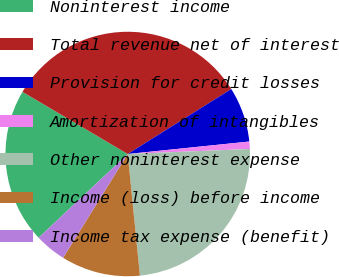<chart> <loc_0><loc_0><loc_500><loc_500><pie_chart><fcel>Noninterest income<fcel>Total revenue net of interest<fcel>Provision for credit losses<fcel>Amortization of intangibles<fcel>Other noninterest expense<fcel>Income (loss) before income<fcel>Income tax expense (benefit)<nl><fcel>20.5%<fcel>32.59%<fcel>7.29%<fcel>0.97%<fcel>24.07%<fcel>10.46%<fcel>4.13%<nl></chart> 